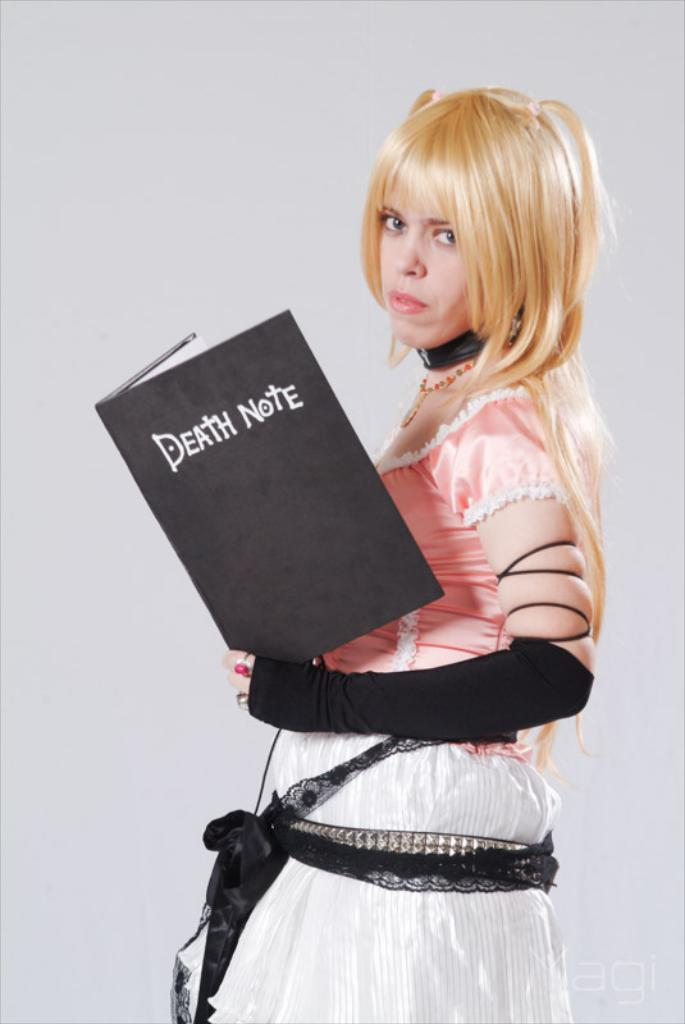Who is the main subject in the image? There is a girl in the image. What is the girl holding in the image? The girl is holding a book. What type of quilt is the girl sitting on in the image? There is no quilt present in the image; the girl is holding a book. How many bikes can be seen in the image? There are no bikes present in the image; the girl is holding a book. 